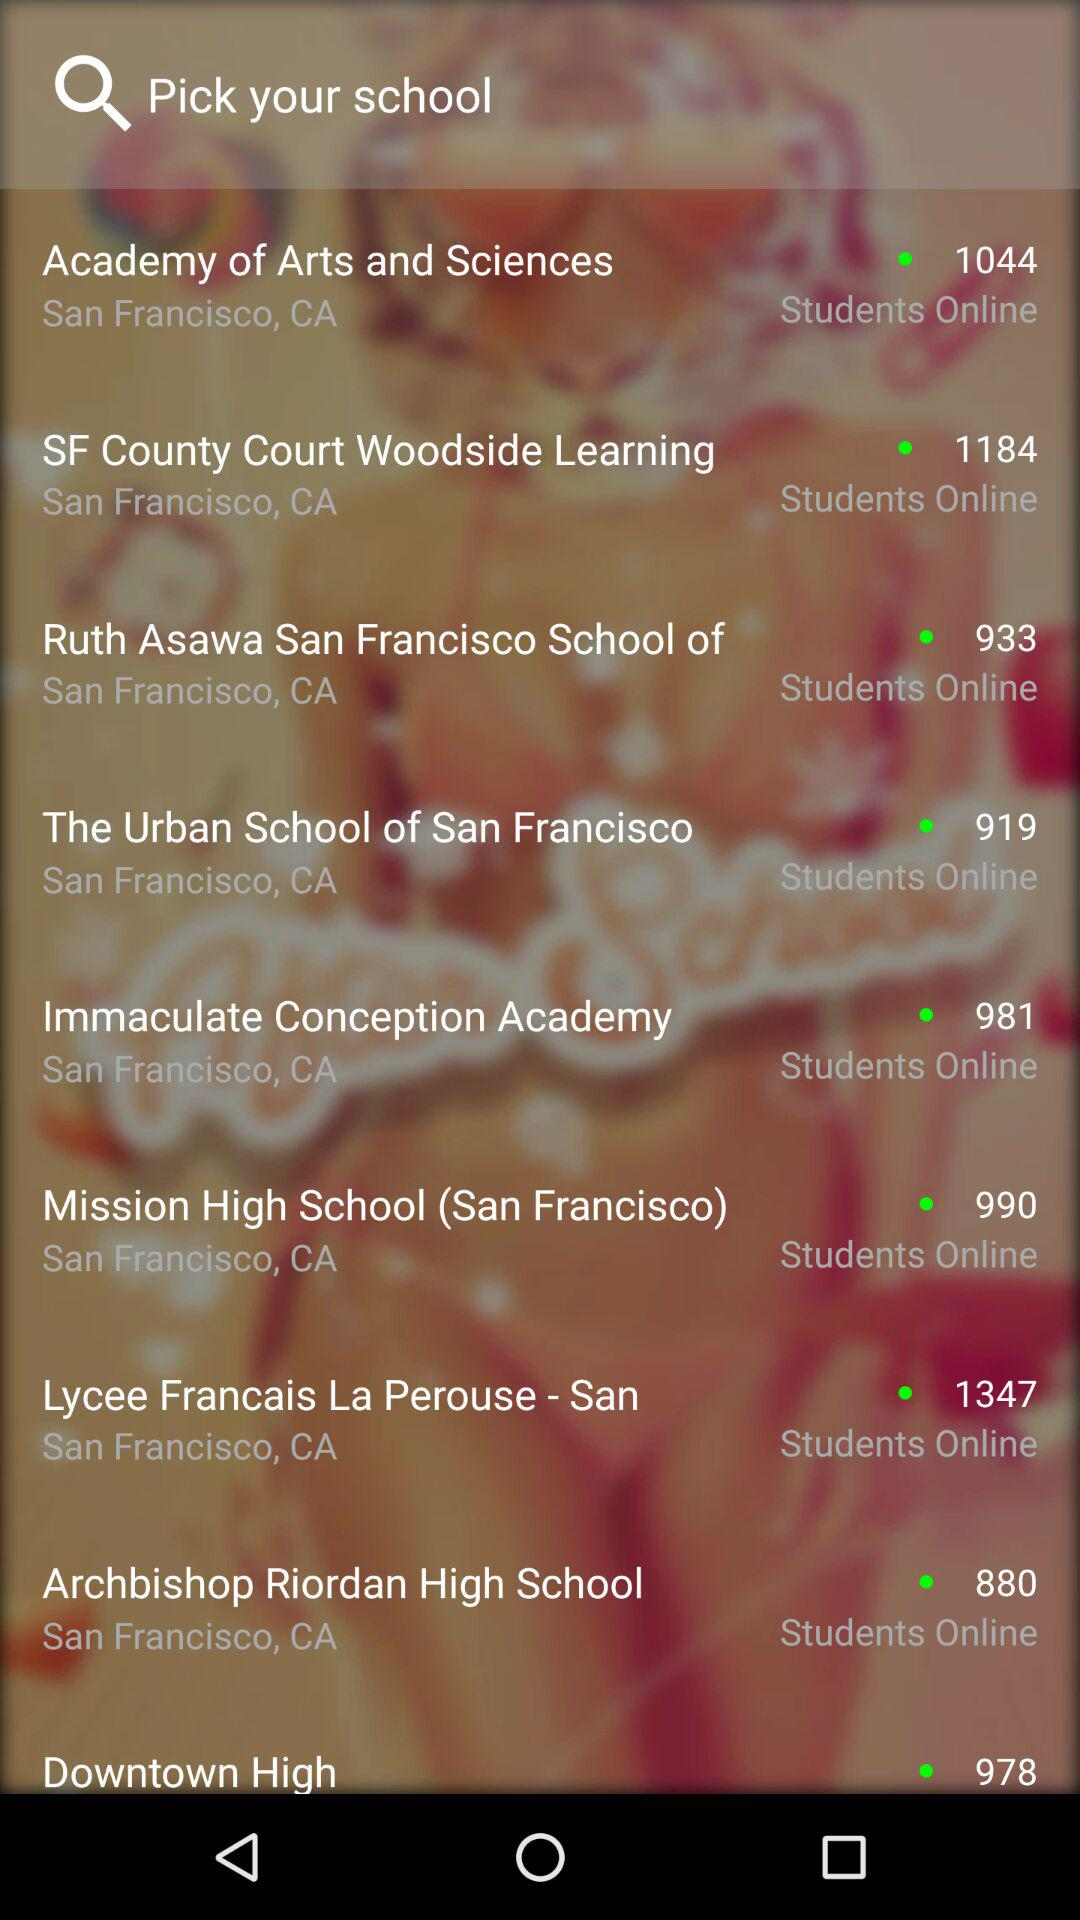What is the location of "The Urban School of San Francisco"? The location is San Francisco, California. 